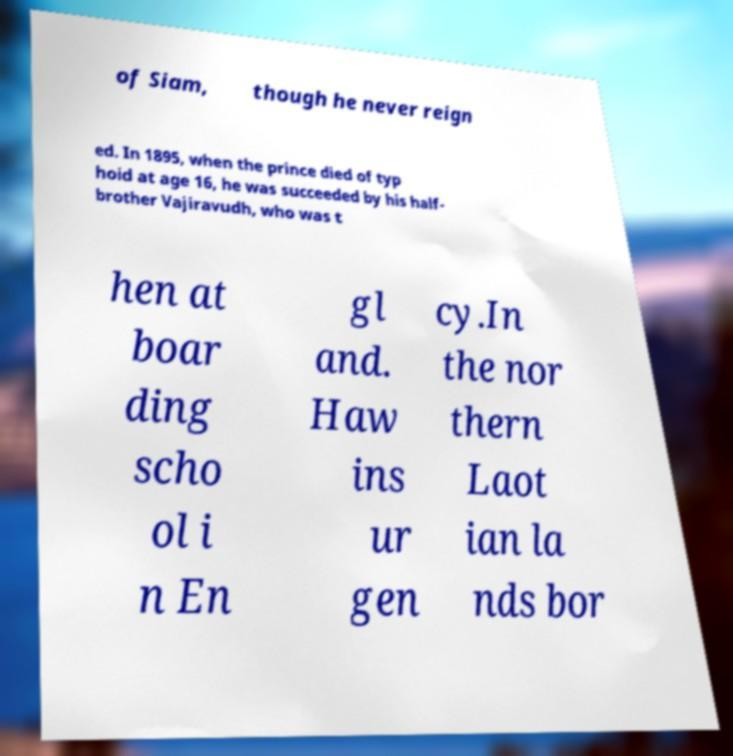Could you extract and type out the text from this image? of Siam, though he never reign ed. In 1895, when the prince died of typ hoid at age 16, he was succeeded by his half- brother Vajiravudh, who was t hen at boar ding scho ol i n En gl and. Haw ins ur gen cy.In the nor thern Laot ian la nds bor 